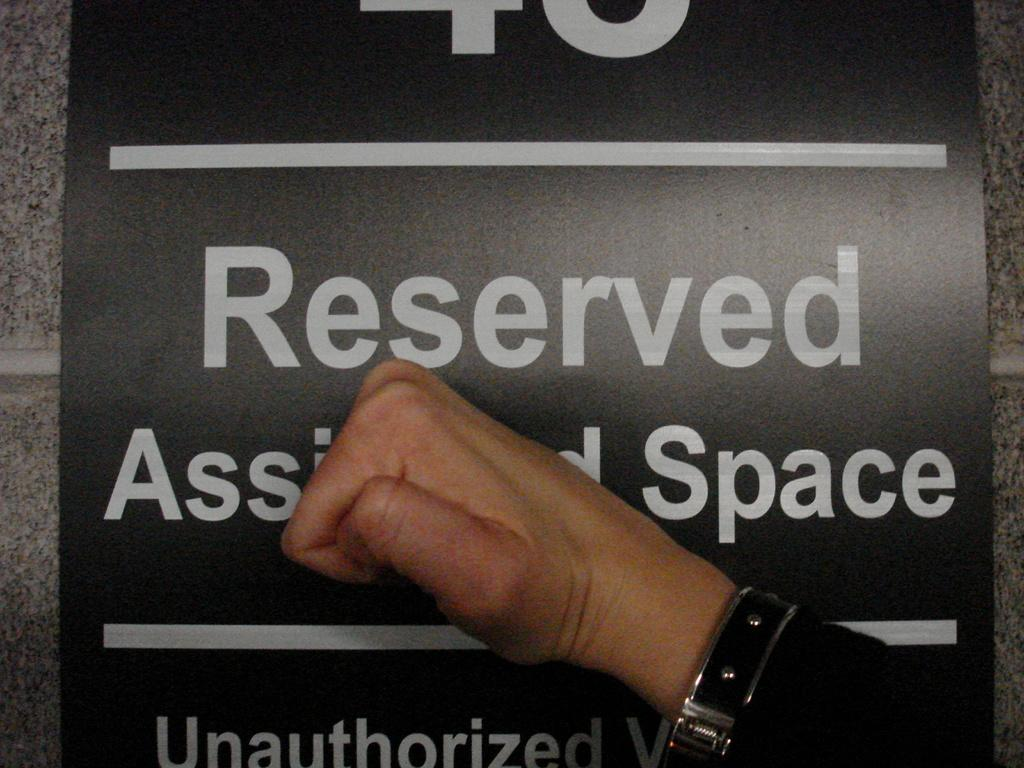<image>
Share a concise interpretation of the image provided. A hand clenched into a fist covering a "Reserved Space"sign. 